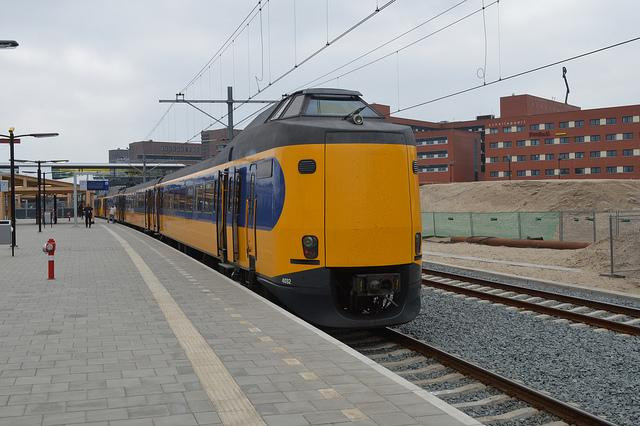What substance can be obtained from the red object? water 